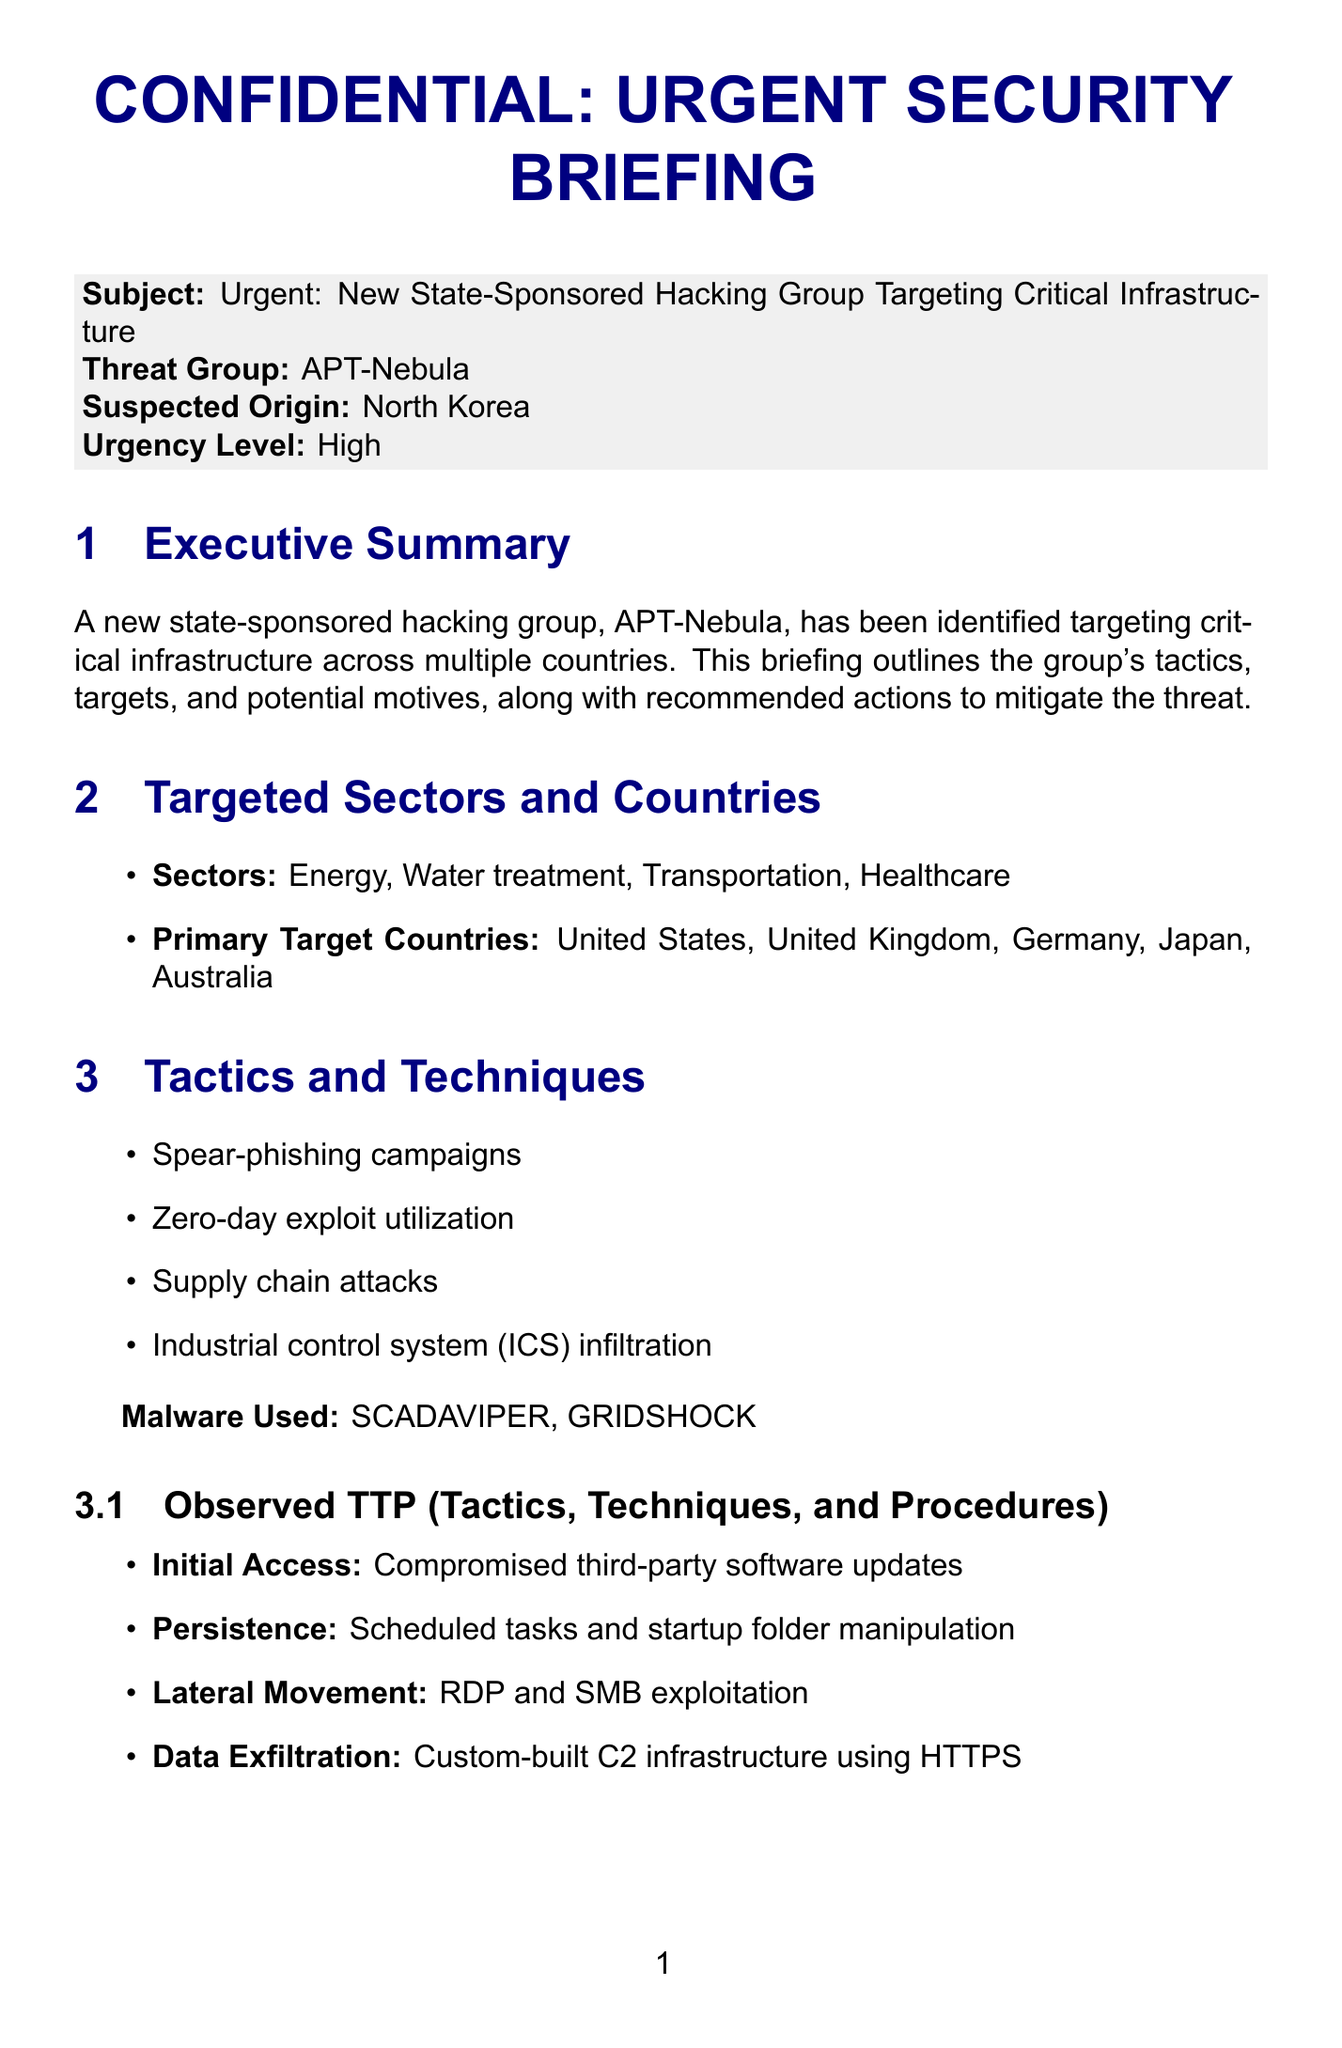What is the name of the hacking group? The hacking group identified in the document is named APT-Nebula.
Answer: APT-Nebula Which country is suspected to be the origin of APT-Nebula? The document states that North Korea is the suspected origin of the hacking group.
Answer: North Korea What sector is NOT targeted by APT-Nebula? The sectors targeted include Energy, Water treatment, Transportation, and Healthcare; therefore, any sector outside these is not targeted.
Answer: (Any sector outside the listed ones) What malware is used by APT-Nebula? The document lists SCADAVIPER and GRIDSHOCK as the malware used by the group.
Answer: SCADAVIPER, GRIDSHOCK What was the impact of the incident on May 15, 2023? The incident on that date involved a temporary outage affecting 50,000 customers.
Answer: Temporary outage affecting 50,000 customers What is one of the possible motives stated in the document? The document outlines several motives including geopolitical leverage, economic disruption, intelligence gathering, or preparation for future cyber-physical attacks.
Answer: Geopolitical leverage What immediate action is recommended for organizations? The document recommends patching all identified vulnerabilities and conducting a full system audit as an immediate action.
Answer: Patch all identified vulnerabilities and conduct a full system audit Who are the relevant agencies listed in the document? Relevant agencies include Cybersecurity and Infrastructure Security Agency (CISA), National Cyber Security Centre (NCSC), Bundesamt für Sicherheit in der Informationstechnik (BSI), and Australian Cyber Security Centre (ACSC).
Answer: CISA, NCSC, BSI, ACSC What is the urgency level of the threat? The document states that the urgency level is high regarding the threat posed by APT-Nebula.
Answer: High 